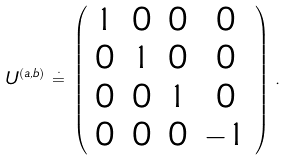<formula> <loc_0><loc_0><loc_500><loc_500>U ^ { ( a , b ) } \, \stackrel { \cdot } { = } \, \left ( \begin{array} { c c c c } 1 & 0 & 0 & 0 \\ 0 & 1 & 0 & 0 \\ 0 & 0 & 1 & 0 \\ 0 & 0 & 0 & - 1 \end{array} \right ) \, .</formula> 